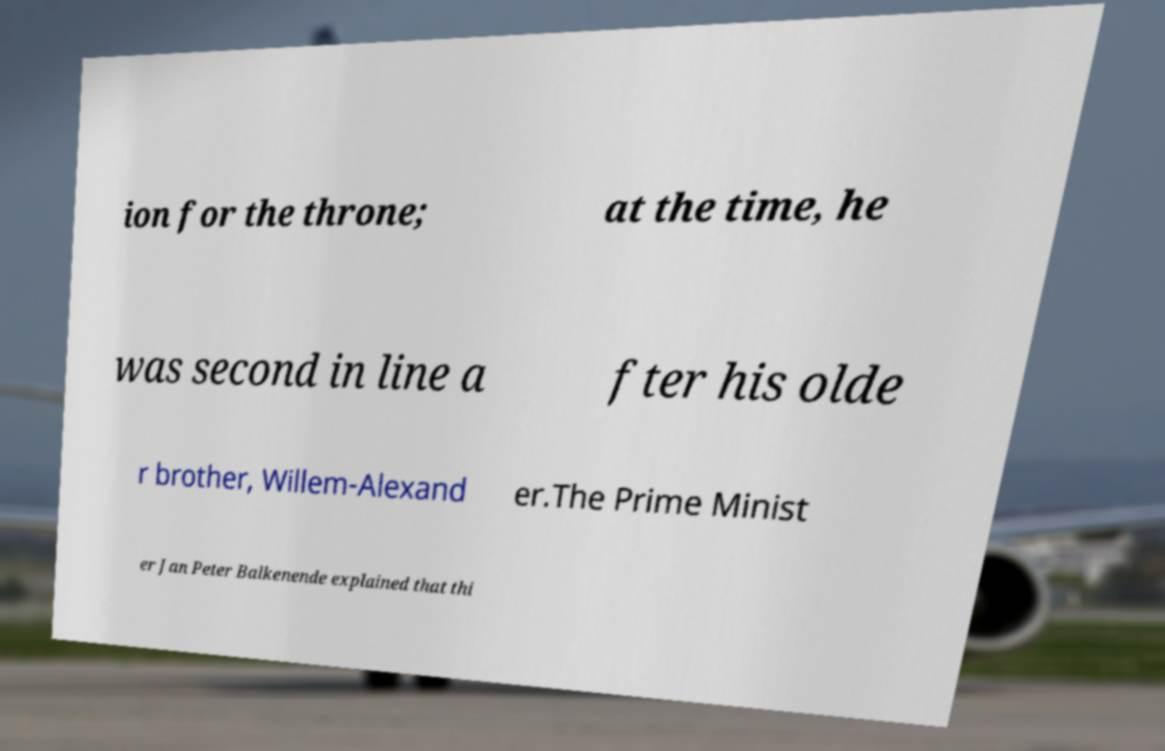I need the written content from this picture converted into text. Can you do that? ion for the throne; at the time, he was second in line a fter his olde r brother, Willem-Alexand er.The Prime Minist er Jan Peter Balkenende explained that thi 